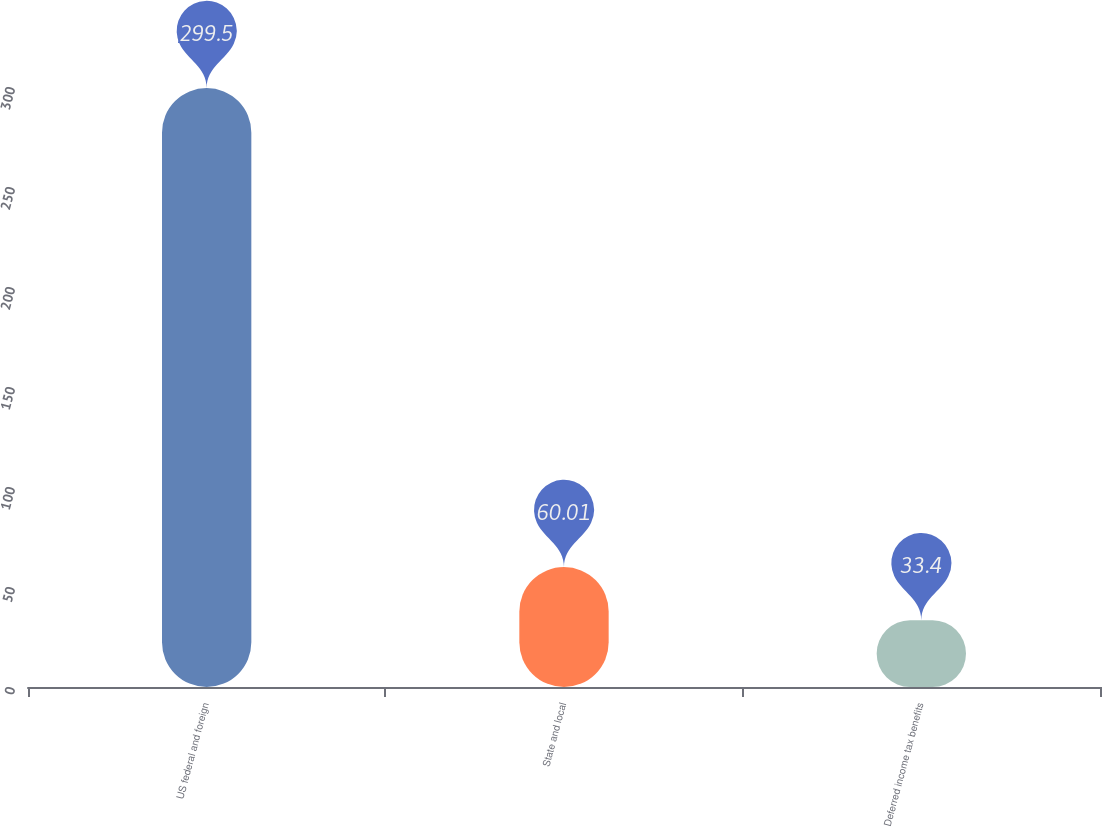Convert chart to OTSL. <chart><loc_0><loc_0><loc_500><loc_500><bar_chart><fcel>US federal and foreign<fcel>State and local<fcel>Deferred income tax benefits<nl><fcel>299.5<fcel>60.01<fcel>33.4<nl></chart> 